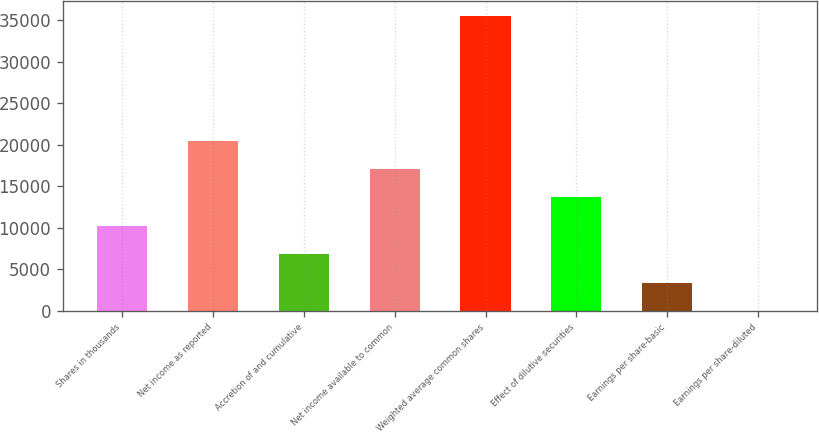<chart> <loc_0><loc_0><loc_500><loc_500><bar_chart><fcel>Shares in thousands<fcel>Net income as reported<fcel>Accretion of and cumulative<fcel>Net income available to common<fcel>Weighted average common shares<fcel>Effect of dilutive securities<fcel>Earnings per share-basic<fcel>Earnings per share-diluted<nl><fcel>10243.9<fcel>20487.7<fcel>6829.32<fcel>17073.1<fcel>35520.6<fcel>13658.5<fcel>3414.74<fcel>0.15<nl></chart> 